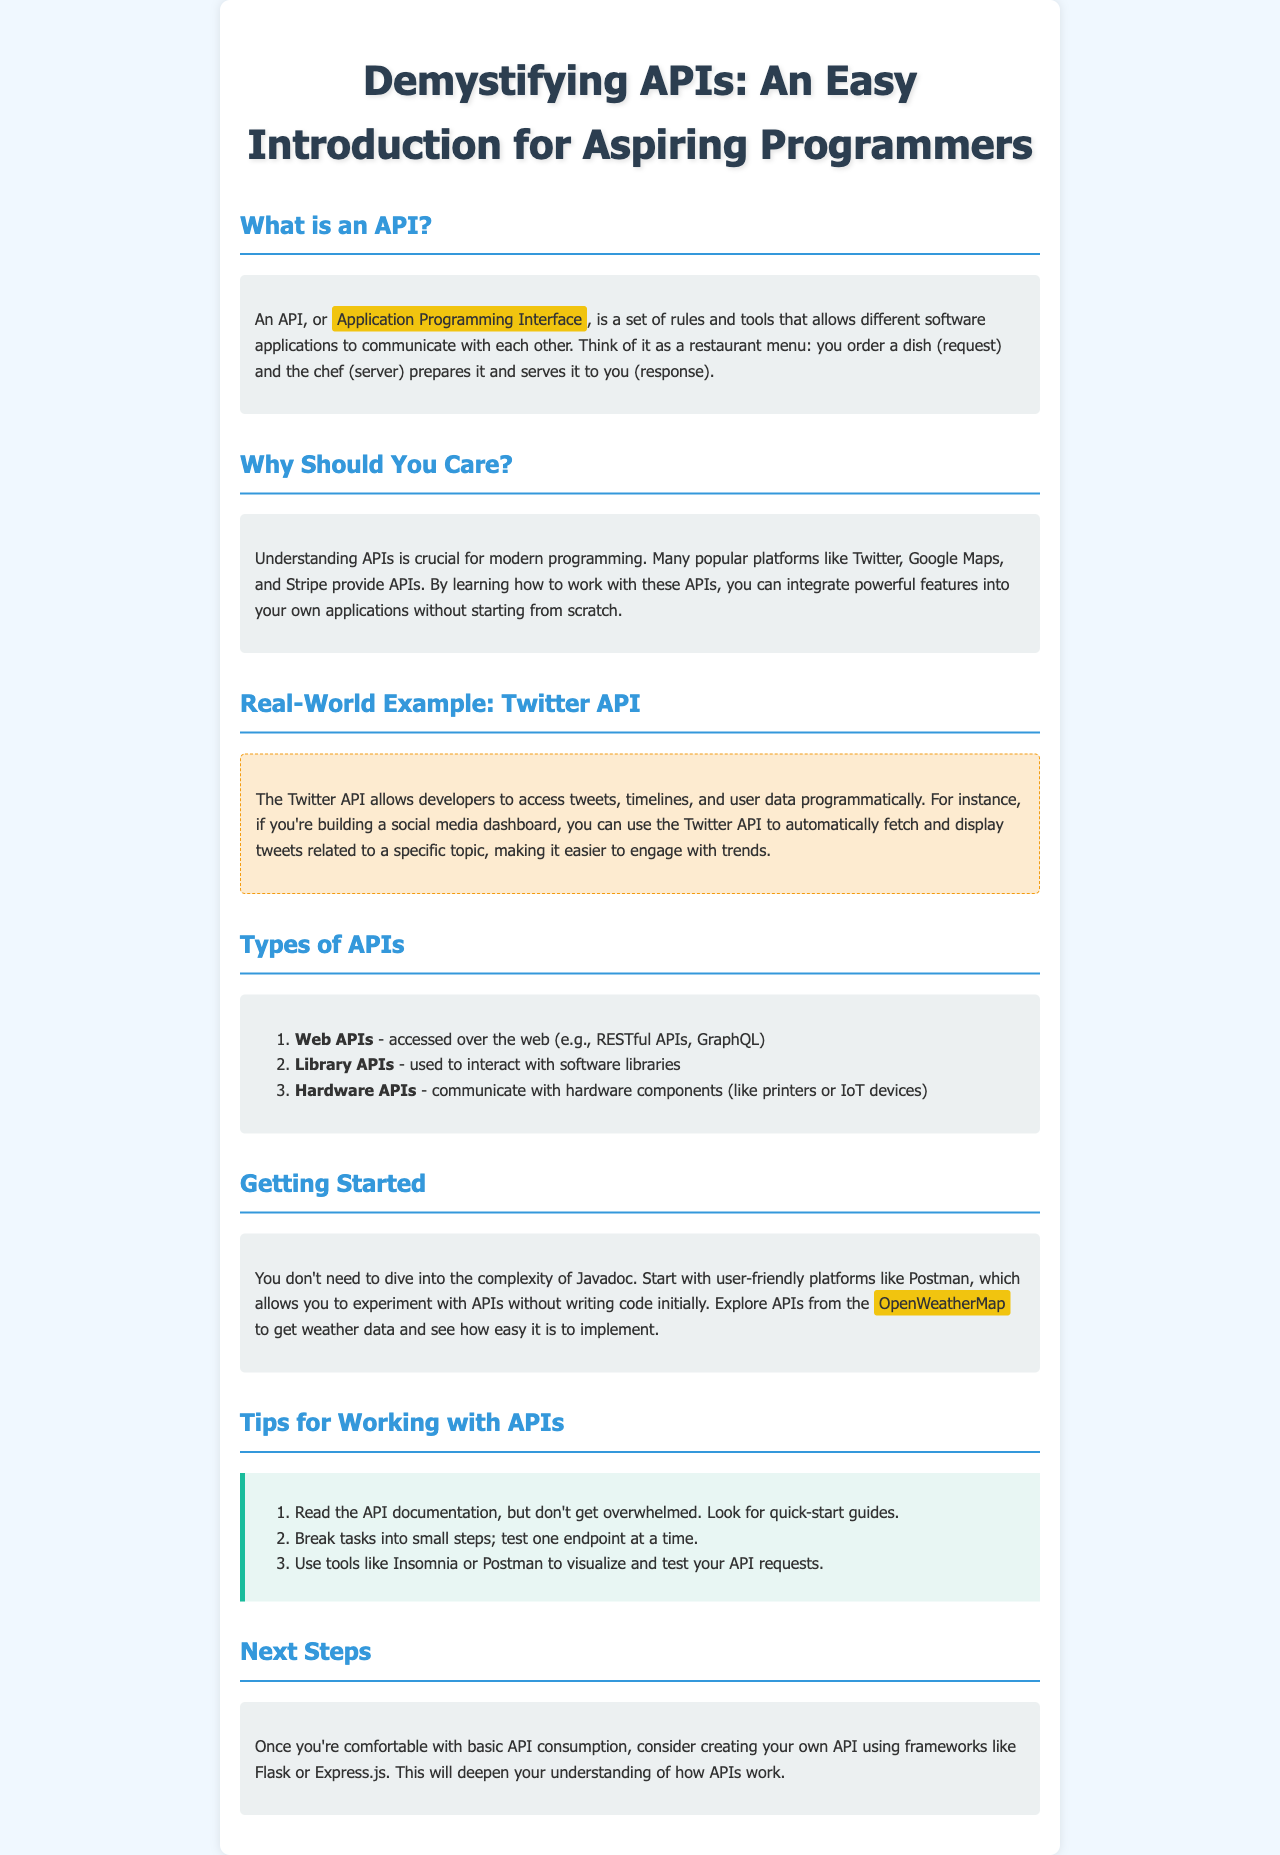What does API stand for? The acronym API refers to Application Programming Interface, as explained in the document.
Answer: Application Programming Interface Why are APIs important? The document explains that learning APIs allows integration of features into applications without starting from scratch.
Answer: Integration of features What example is given for a real-world API? The document mentions the Twitter API as a specific example.
Answer: Twitter API How many types of APIs are listed? There are three types of APIs mentioned in the document.
Answer: Three What tool is recommended to start experimenting with APIs? Postman is suggested as a user-friendly platform for experimenting with APIs.
Answer: Postman What platform can be explored for weather data? The document suggests using OpenWeatherMap for fetching weather data.
Answer: OpenWeatherMap Which frameworks are mentioned for creating your own API? Flask and Express.js are the frameworks mentioned for API creation.
Answer: Flask or Express.js What should you look for in API documentation? The document recommends looking for quick-start guides in API documentation.
Answer: Quick-start guides How should tasks be approached when working with APIs? Tasks should be broken into small steps and tested one endpoint at a time, according to the document.
Answer: Small steps 